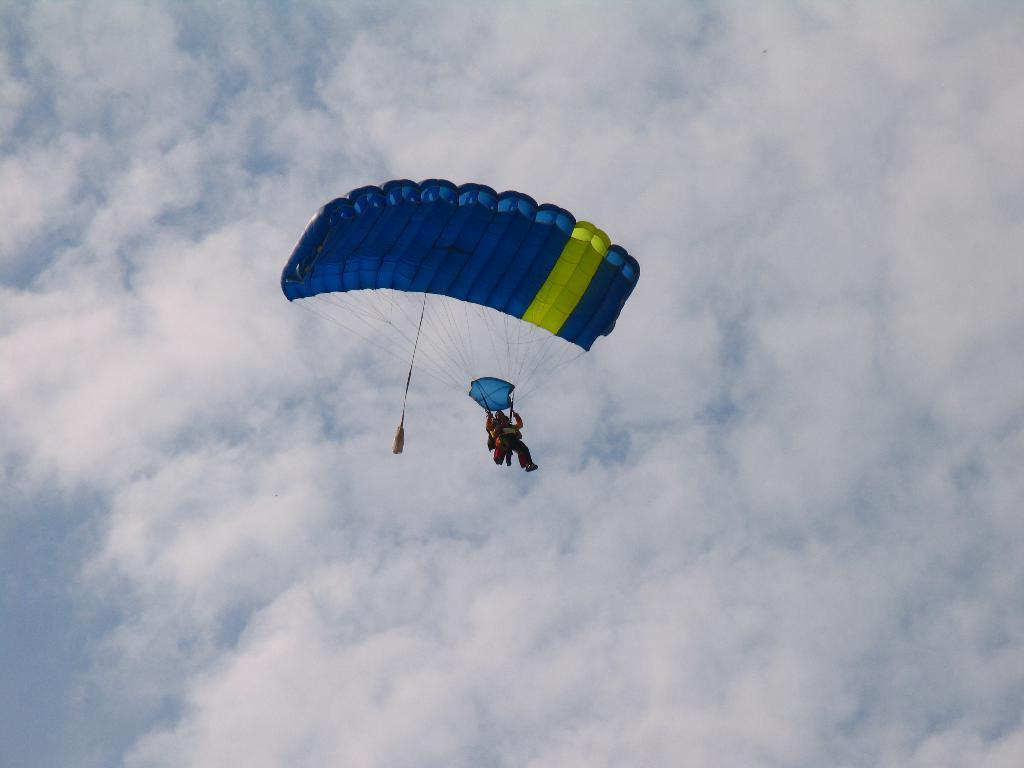What activity is the person in the image engaged in? The person is parasailing in the image. What is the weather like in the image? The sky appears cloudy in the image. What type of birthday cake is being served in the image? There is no birthday cake or any reference to a birthday celebration in the image. 